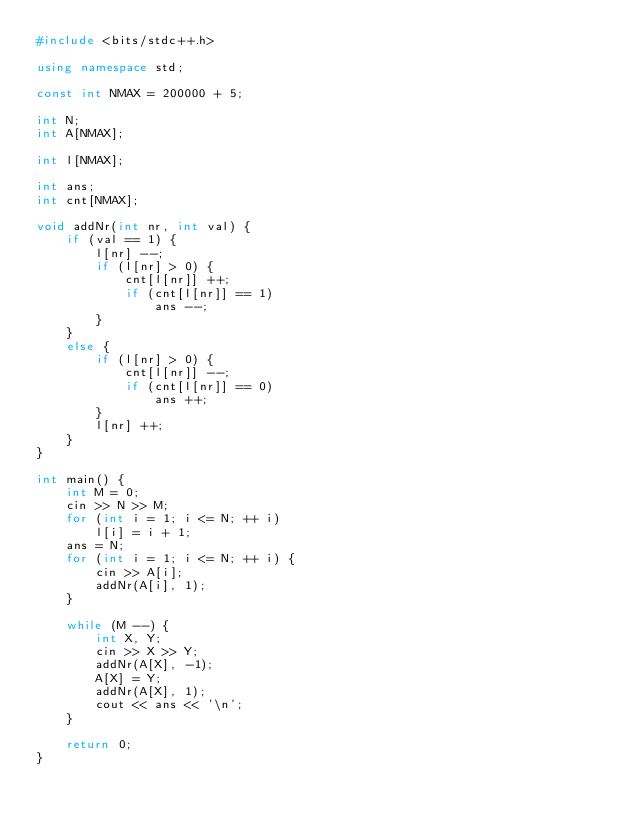Convert code to text. <code><loc_0><loc_0><loc_500><loc_500><_C++_>#include <bits/stdc++.h>

using namespace std;

const int NMAX = 200000 + 5;

int N;
int A[NMAX];

int l[NMAX];

int ans;
int cnt[NMAX];

void addNr(int nr, int val) {
    if (val == 1) {
        l[nr] --;
        if (l[nr] > 0) {
            cnt[l[nr]] ++;
            if (cnt[l[nr]] == 1)
                ans --;
        }
    }
    else {
        if (l[nr] > 0) {
            cnt[l[nr]] --;
            if (cnt[l[nr]] == 0)
                ans ++;
        }
        l[nr] ++;
    }
}

int main() {
    int M = 0;
    cin >> N >> M;
    for (int i = 1; i <= N; ++ i)
        l[i] = i + 1;
    ans = N;
    for (int i = 1; i <= N; ++ i) {
        cin >> A[i];
        addNr(A[i], 1);
    }

    while (M --) {
        int X, Y;
        cin >> X >> Y;
        addNr(A[X], -1);
        A[X] = Y;
        addNr(A[X], 1);
        cout << ans << '\n';
    }

    return 0;    
}</code> 